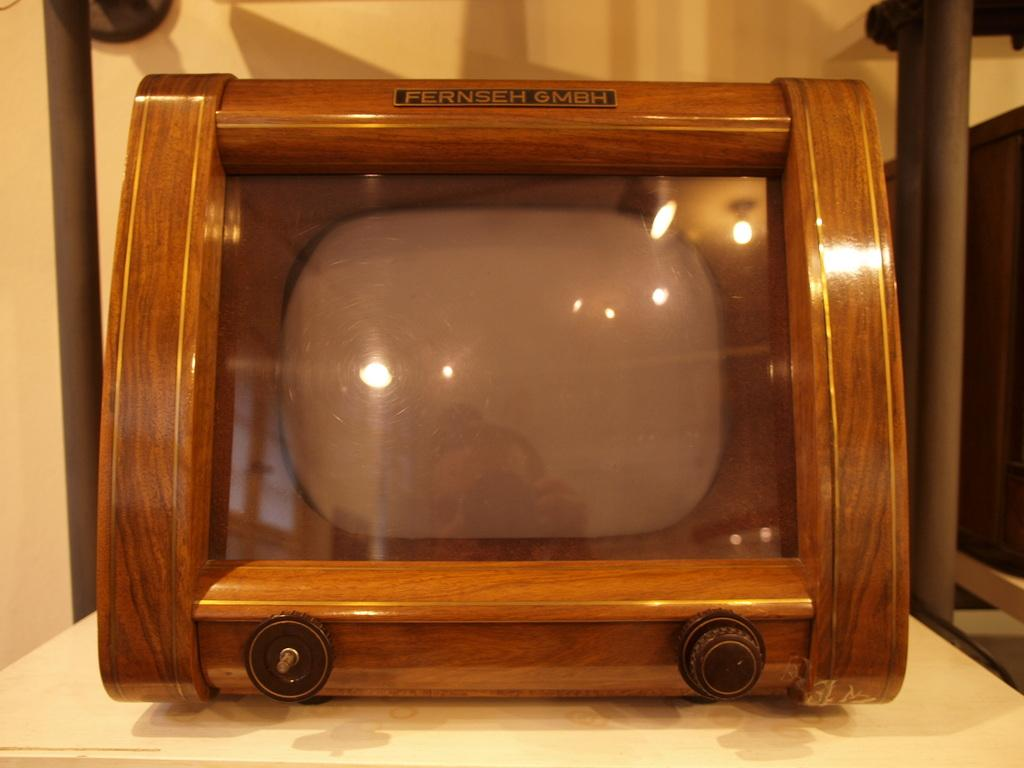<image>
Write a terse but informative summary of the picture. A very old classic tube television made by Fernseh 